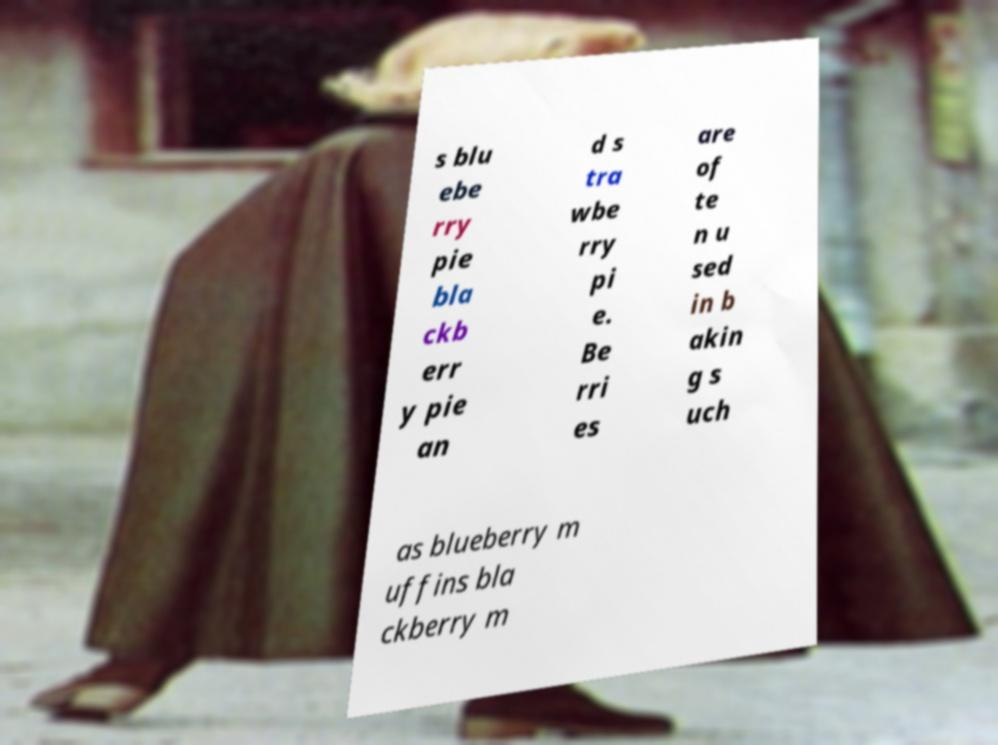Please identify and transcribe the text found in this image. s blu ebe rry pie bla ckb err y pie an d s tra wbe rry pi e. Be rri es are of te n u sed in b akin g s uch as blueberry m uffins bla ckberry m 